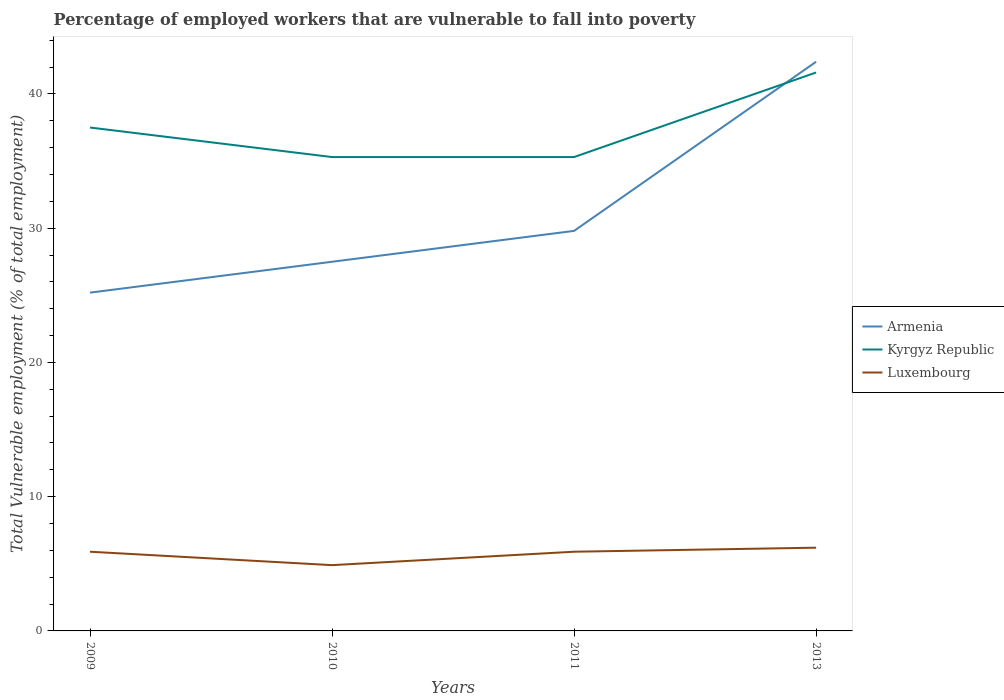How many different coloured lines are there?
Offer a terse response. 3. Is the number of lines equal to the number of legend labels?
Provide a succinct answer. Yes. Across all years, what is the maximum percentage of employed workers who are vulnerable to fall into poverty in Luxembourg?
Your response must be concise. 4.9. In which year was the percentage of employed workers who are vulnerable to fall into poverty in Armenia maximum?
Keep it short and to the point. 2009. What is the total percentage of employed workers who are vulnerable to fall into poverty in Kyrgyz Republic in the graph?
Your answer should be compact. 2.2. What is the difference between the highest and the second highest percentage of employed workers who are vulnerable to fall into poverty in Kyrgyz Republic?
Provide a short and direct response. 6.3. What is the difference between the highest and the lowest percentage of employed workers who are vulnerable to fall into poverty in Kyrgyz Republic?
Ensure brevity in your answer.  2. How many lines are there?
Give a very brief answer. 3. How many years are there in the graph?
Provide a succinct answer. 4. What is the difference between two consecutive major ticks on the Y-axis?
Your answer should be very brief. 10. How many legend labels are there?
Keep it short and to the point. 3. How are the legend labels stacked?
Your response must be concise. Vertical. What is the title of the graph?
Keep it short and to the point. Percentage of employed workers that are vulnerable to fall into poverty. What is the label or title of the X-axis?
Offer a terse response. Years. What is the label or title of the Y-axis?
Ensure brevity in your answer.  Total Vulnerable employment (% of total employment). What is the Total Vulnerable employment (% of total employment) of Armenia in 2009?
Offer a terse response. 25.2. What is the Total Vulnerable employment (% of total employment) of Kyrgyz Republic in 2009?
Make the answer very short. 37.5. What is the Total Vulnerable employment (% of total employment) in Luxembourg in 2009?
Offer a very short reply. 5.9. What is the Total Vulnerable employment (% of total employment) in Kyrgyz Republic in 2010?
Offer a terse response. 35.3. What is the Total Vulnerable employment (% of total employment) in Luxembourg in 2010?
Your answer should be very brief. 4.9. What is the Total Vulnerable employment (% of total employment) in Armenia in 2011?
Offer a terse response. 29.8. What is the Total Vulnerable employment (% of total employment) in Kyrgyz Republic in 2011?
Ensure brevity in your answer.  35.3. What is the Total Vulnerable employment (% of total employment) of Luxembourg in 2011?
Provide a succinct answer. 5.9. What is the Total Vulnerable employment (% of total employment) in Armenia in 2013?
Give a very brief answer. 42.4. What is the Total Vulnerable employment (% of total employment) of Kyrgyz Republic in 2013?
Offer a very short reply. 41.6. What is the Total Vulnerable employment (% of total employment) in Luxembourg in 2013?
Give a very brief answer. 6.2. Across all years, what is the maximum Total Vulnerable employment (% of total employment) of Armenia?
Provide a short and direct response. 42.4. Across all years, what is the maximum Total Vulnerable employment (% of total employment) of Kyrgyz Republic?
Provide a succinct answer. 41.6. Across all years, what is the maximum Total Vulnerable employment (% of total employment) in Luxembourg?
Ensure brevity in your answer.  6.2. Across all years, what is the minimum Total Vulnerable employment (% of total employment) in Armenia?
Offer a very short reply. 25.2. Across all years, what is the minimum Total Vulnerable employment (% of total employment) of Kyrgyz Republic?
Make the answer very short. 35.3. Across all years, what is the minimum Total Vulnerable employment (% of total employment) in Luxembourg?
Give a very brief answer. 4.9. What is the total Total Vulnerable employment (% of total employment) in Armenia in the graph?
Your answer should be compact. 124.9. What is the total Total Vulnerable employment (% of total employment) in Kyrgyz Republic in the graph?
Your response must be concise. 149.7. What is the total Total Vulnerable employment (% of total employment) of Luxembourg in the graph?
Provide a succinct answer. 22.9. What is the difference between the Total Vulnerable employment (% of total employment) in Luxembourg in 2009 and that in 2010?
Your answer should be very brief. 1. What is the difference between the Total Vulnerable employment (% of total employment) of Armenia in 2009 and that in 2013?
Provide a short and direct response. -17.2. What is the difference between the Total Vulnerable employment (% of total employment) in Kyrgyz Republic in 2009 and that in 2013?
Give a very brief answer. -4.1. What is the difference between the Total Vulnerable employment (% of total employment) of Armenia in 2010 and that in 2011?
Ensure brevity in your answer.  -2.3. What is the difference between the Total Vulnerable employment (% of total employment) in Luxembourg in 2010 and that in 2011?
Your answer should be very brief. -1. What is the difference between the Total Vulnerable employment (% of total employment) in Armenia in 2010 and that in 2013?
Your response must be concise. -14.9. What is the difference between the Total Vulnerable employment (% of total employment) of Kyrgyz Republic in 2010 and that in 2013?
Your response must be concise. -6.3. What is the difference between the Total Vulnerable employment (% of total employment) of Armenia in 2009 and the Total Vulnerable employment (% of total employment) of Luxembourg in 2010?
Ensure brevity in your answer.  20.3. What is the difference between the Total Vulnerable employment (% of total employment) in Kyrgyz Republic in 2009 and the Total Vulnerable employment (% of total employment) in Luxembourg in 2010?
Offer a very short reply. 32.6. What is the difference between the Total Vulnerable employment (% of total employment) of Armenia in 2009 and the Total Vulnerable employment (% of total employment) of Kyrgyz Republic in 2011?
Ensure brevity in your answer.  -10.1. What is the difference between the Total Vulnerable employment (% of total employment) of Armenia in 2009 and the Total Vulnerable employment (% of total employment) of Luxembourg in 2011?
Offer a very short reply. 19.3. What is the difference between the Total Vulnerable employment (% of total employment) of Kyrgyz Republic in 2009 and the Total Vulnerable employment (% of total employment) of Luxembourg in 2011?
Make the answer very short. 31.6. What is the difference between the Total Vulnerable employment (% of total employment) in Armenia in 2009 and the Total Vulnerable employment (% of total employment) in Kyrgyz Republic in 2013?
Provide a succinct answer. -16.4. What is the difference between the Total Vulnerable employment (% of total employment) in Kyrgyz Republic in 2009 and the Total Vulnerable employment (% of total employment) in Luxembourg in 2013?
Ensure brevity in your answer.  31.3. What is the difference between the Total Vulnerable employment (% of total employment) in Armenia in 2010 and the Total Vulnerable employment (% of total employment) in Luxembourg in 2011?
Offer a terse response. 21.6. What is the difference between the Total Vulnerable employment (% of total employment) in Kyrgyz Republic in 2010 and the Total Vulnerable employment (% of total employment) in Luxembourg in 2011?
Ensure brevity in your answer.  29.4. What is the difference between the Total Vulnerable employment (% of total employment) in Armenia in 2010 and the Total Vulnerable employment (% of total employment) in Kyrgyz Republic in 2013?
Your answer should be very brief. -14.1. What is the difference between the Total Vulnerable employment (% of total employment) in Armenia in 2010 and the Total Vulnerable employment (% of total employment) in Luxembourg in 2013?
Ensure brevity in your answer.  21.3. What is the difference between the Total Vulnerable employment (% of total employment) of Kyrgyz Republic in 2010 and the Total Vulnerable employment (% of total employment) of Luxembourg in 2013?
Keep it short and to the point. 29.1. What is the difference between the Total Vulnerable employment (% of total employment) in Armenia in 2011 and the Total Vulnerable employment (% of total employment) in Luxembourg in 2013?
Offer a very short reply. 23.6. What is the difference between the Total Vulnerable employment (% of total employment) of Kyrgyz Republic in 2011 and the Total Vulnerable employment (% of total employment) of Luxembourg in 2013?
Provide a short and direct response. 29.1. What is the average Total Vulnerable employment (% of total employment) in Armenia per year?
Offer a terse response. 31.23. What is the average Total Vulnerable employment (% of total employment) of Kyrgyz Republic per year?
Ensure brevity in your answer.  37.42. What is the average Total Vulnerable employment (% of total employment) in Luxembourg per year?
Your answer should be very brief. 5.72. In the year 2009, what is the difference between the Total Vulnerable employment (% of total employment) of Armenia and Total Vulnerable employment (% of total employment) of Kyrgyz Republic?
Make the answer very short. -12.3. In the year 2009, what is the difference between the Total Vulnerable employment (% of total employment) of Armenia and Total Vulnerable employment (% of total employment) of Luxembourg?
Give a very brief answer. 19.3. In the year 2009, what is the difference between the Total Vulnerable employment (% of total employment) in Kyrgyz Republic and Total Vulnerable employment (% of total employment) in Luxembourg?
Give a very brief answer. 31.6. In the year 2010, what is the difference between the Total Vulnerable employment (% of total employment) of Armenia and Total Vulnerable employment (% of total employment) of Luxembourg?
Your answer should be compact. 22.6. In the year 2010, what is the difference between the Total Vulnerable employment (% of total employment) of Kyrgyz Republic and Total Vulnerable employment (% of total employment) of Luxembourg?
Provide a short and direct response. 30.4. In the year 2011, what is the difference between the Total Vulnerable employment (% of total employment) of Armenia and Total Vulnerable employment (% of total employment) of Kyrgyz Republic?
Offer a very short reply. -5.5. In the year 2011, what is the difference between the Total Vulnerable employment (% of total employment) in Armenia and Total Vulnerable employment (% of total employment) in Luxembourg?
Offer a very short reply. 23.9. In the year 2011, what is the difference between the Total Vulnerable employment (% of total employment) of Kyrgyz Republic and Total Vulnerable employment (% of total employment) of Luxembourg?
Offer a very short reply. 29.4. In the year 2013, what is the difference between the Total Vulnerable employment (% of total employment) of Armenia and Total Vulnerable employment (% of total employment) of Kyrgyz Republic?
Provide a succinct answer. 0.8. In the year 2013, what is the difference between the Total Vulnerable employment (% of total employment) in Armenia and Total Vulnerable employment (% of total employment) in Luxembourg?
Keep it short and to the point. 36.2. In the year 2013, what is the difference between the Total Vulnerable employment (% of total employment) in Kyrgyz Republic and Total Vulnerable employment (% of total employment) in Luxembourg?
Provide a short and direct response. 35.4. What is the ratio of the Total Vulnerable employment (% of total employment) in Armenia in 2009 to that in 2010?
Your answer should be compact. 0.92. What is the ratio of the Total Vulnerable employment (% of total employment) of Kyrgyz Republic in 2009 to that in 2010?
Offer a terse response. 1.06. What is the ratio of the Total Vulnerable employment (% of total employment) of Luxembourg in 2009 to that in 2010?
Your answer should be compact. 1.2. What is the ratio of the Total Vulnerable employment (% of total employment) of Armenia in 2009 to that in 2011?
Give a very brief answer. 0.85. What is the ratio of the Total Vulnerable employment (% of total employment) in Kyrgyz Republic in 2009 to that in 2011?
Keep it short and to the point. 1.06. What is the ratio of the Total Vulnerable employment (% of total employment) of Armenia in 2009 to that in 2013?
Make the answer very short. 0.59. What is the ratio of the Total Vulnerable employment (% of total employment) of Kyrgyz Republic in 2009 to that in 2013?
Your answer should be compact. 0.9. What is the ratio of the Total Vulnerable employment (% of total employment) in Luxembourg in 2009 to that in 2013?
Keep it short and to the point. 0.95. What is the ratio of the Total Vulnerable employment (% of total employment) of Armenia in 2010 to that in 2011?
Make the answer very short. 0.92. What is the ratio of the Total Vulnerable employment (% of total employment) in Kyrgyz Republic in 2010 to that in 2011?
Provide a short and direct response. 1. What is the ratio of the Total Vulnerable employment (% of total employment) of Luxembourg in 2010 to that in 2011?
Your response must be concise. 0.83. What is the ratio of the Total Vulnerable employment (% of total employment) in Armenia in 2010 to that in 2013?
Your answer should be compact. 0.65. What is the ratio of the Total Vulnerable employment (% of total employment) in Kyrgyz Republic in 2010 to that in 2013?
Keep it short and to the point. 0.85. What is the ratio of the Total Vulnerable employment (% of total employment) of Luxembourg in 2010 to that in 2013?
Offer a very short reply. 0.79. What is the ratio of the Total Vulnerable employment (% of total employment) of Armenia in 2011 to that in 2013?
Your answer should be very brief. 0.7. What is the ratio of the Total Vulnerable employment (% of total employment) of Kyrgyz Republic in 2011 to that in 2013?
Provide a succinct answer. 0.85. What is the ratio of the Total Vulnerable employment (% of total employment) of Luxembourg in 2011 to that in 2013?
Your response must be concise. 0.95. What is the difference between the highest and the second highest Total Vulnerable employment (% of total employment) of Armenia?
Offer a very short reply. 12.6. What is the difference between the highest and the lowest Total Vulnerable employment (% of total employment) of Armenia?
Give a very brief answer. 17.2. What is the difference between the highest and the lowest Total Vulnerable employment (% of total employment) of Kyrgyz Republic?
Your answer should be compact. 6.3. What is the difference between the highest and the lowest Total Vulnerable employment (% of total employment) in Luxembourg?
Give a very brief answer. 1.3. 